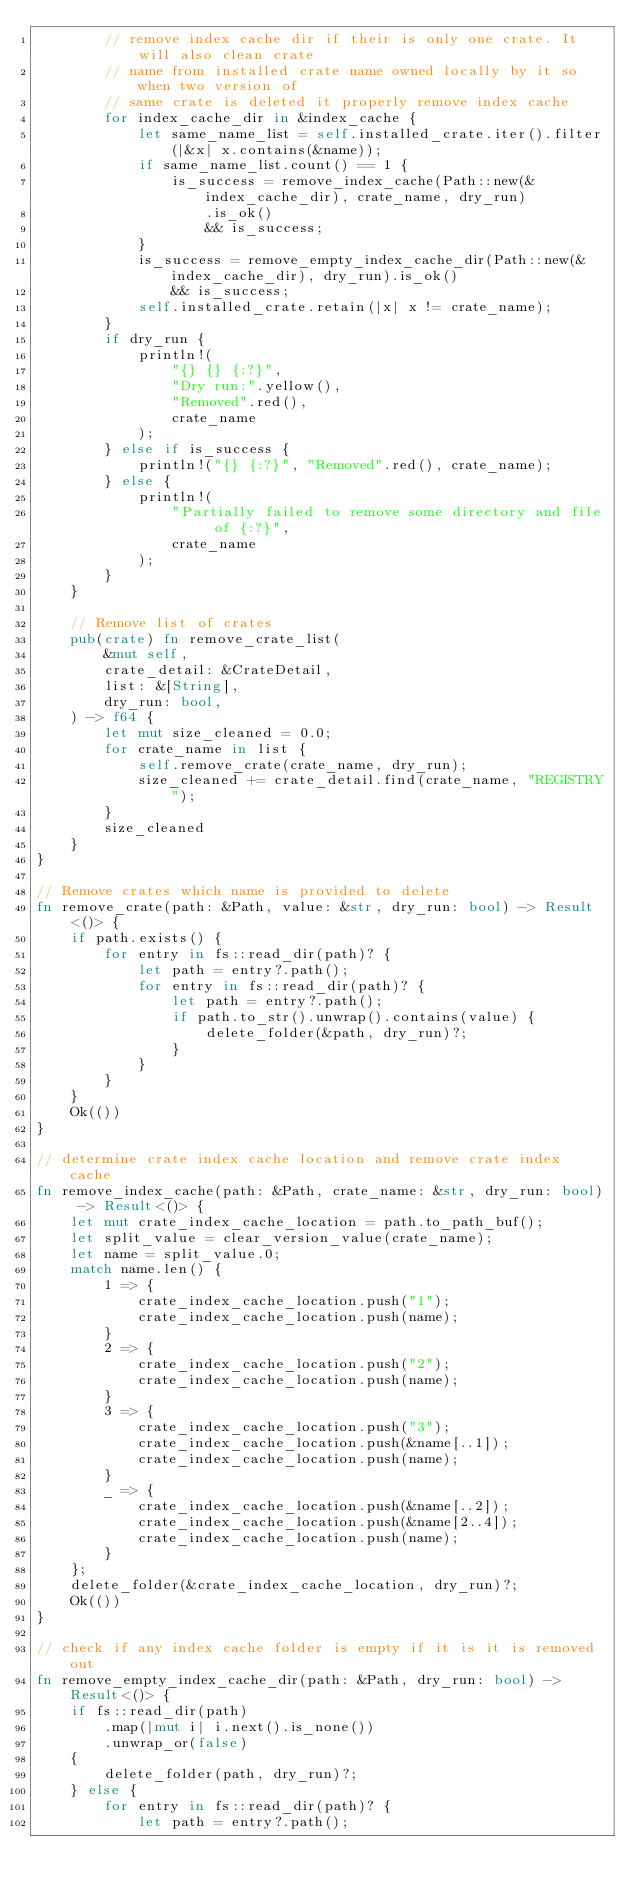Convert code to text. <code><loc_0><loc_0><loc_500><loc_500><_Rust_>        // remove index cache dir if their is only one crate. It will also clean crate
        // name from installed crate name owned locally by it so when two version of
        // same crate is deleted it properly remove index cache
        for index_cache_dir in &index_cache {
            let same_name_list = self.installed_crate.iter().filter(|&x| x.contains(&name));
            if same_name_list.count() == 1 {
                is_success = remove_index_cache(Path::new(&index_cache_dir), crate_name, dry_run)
                    .is_ok()
                    && is_success;
            }
            is_success = remove_empty_index_cache_dir(Path::new(&index_cache_dir), dry_run).is_ok()
                && is_success;
            self.installed_crate.retain(|x| x != crate_name);
        }
        if dry_run {
            println!(
                "{} {} {:?}",
                "Dry run:".yellow(),
                "Removed".red(),
                crate_name
            );
        } else if is_success {
            println!("{} {:?}", "Removed".red(), crate_name);
        } else {
            println!(
                "Partially failed to remove some directory and file of {:?}",
                crate_name
            );
        }
    }

    // Remove list of crates
    pub(crate) fn remove_crate_list(
        &mut self,
        crate_detail: &CrateDetail,
        list: &[String],
        dry_run: bool,
    ) -> f64 {
        let mut size_cleaned = 0.0;
        for crate_name in list {
            self.remove_crate(crate_name, dry_run);
            size_cleaned += crate_detail.find(crate_name, "REGISTRY");
        }
        size_cleaned
    }
}

// Remove crates which name is provided to delete
fn remove_crate(path: &Path, value: &str, dry_run: bool) -> Result<()> {
    if path.exists() {
        for entry in fs::read_dir(path)? {
            let path = entry?.path();
            for entry in fs::read_dir(path)? {
                let path = entry?.path();
                if path.to_str().unwrap().contains(value) {
                    delete_folder(&path, dry_run)?;
                }
            }
        }
    }
    Ok(())
}

// determine crate index cache location and remove crate index cache
fn remove_index_cache(path: &Path, crate_name: &str, dry_run: bool) -> Result<()> {
    let mut crate_index_cache_location = path.to_path_buf();
    let split_value = clear_version_value(crate_name);
    let name = split_value.0;
    match name.len() {
        1 => {
            crate_index_cache_location.push("1");
            crate_index_cache_location.push(name);
        }
        2 => {
            crate_index_cache_location.push("2");
            crate_index_cache_location.push(name);
        }
        3 => {
            crate_index_cache_location.push("3");
            crate_index_cache_location.push(&name[..1]);
            crate_index_cache_location.push(name);
        }
        _ => {
            crate_index_cache_location.push(&name[..2]);
            crate_index_cache_location.push(&name[2..4]);
            crate_index_cache_location.push(name);
        }
    };
    delete_folder(&crate_index_cache_location, dry_run)?;
    Ok(())
}

// check if any index cache folder is empty if it is it is removed out
fn remove_empty_index_cache_dir(path: &Path, dry_run: bool) -> Result<()> {
    if fs::read_dir(path)
        .map(|mut i| i.next().is_none())
        .unwrap_or(false)
    {
        delete_folder(path, dry_run)?;
    } else {
        for entry in fs::read_dir(path)? {
            let path = entry?.path();</code> 